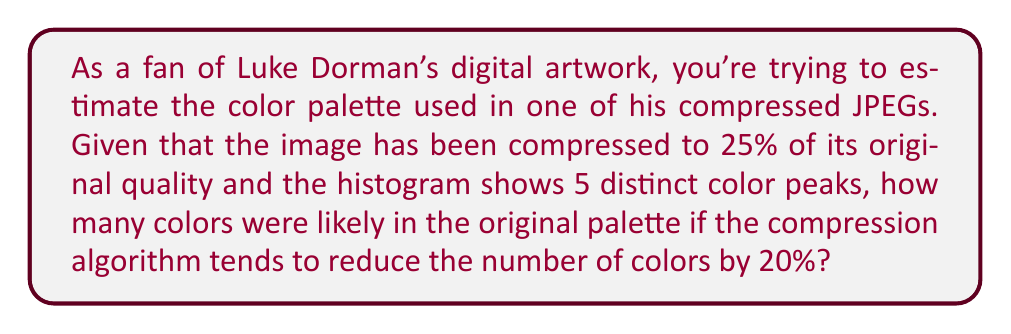Give your solution to this math problem. To solve this problem, we need to follow these steps:

1. Identify the number of color peaks in the compressed image:
   The histogram shows 5 distinct color peaks.

2. Understand the compression effect on colors:
   The compression algorithm reduces the number of colors by 20%.

3. Set up an equation to represent the relationship:
   Let $x$ be the number of colors in the original palette.
   After compression: $x - 0.2x = 5$

4. Solve the equation:
   $$x - 0.2x = 5$$
   $$0.8x = 5$$
   $$x = \frac{5}{0.8} = 6.25$$

5. Round to the nearest whole number:
   Since we can't have a fractional number of colors, we round 6.25 to 6.

Therefore, the original palette likely contained 6 colors before compression.
Answer: 6 colors 